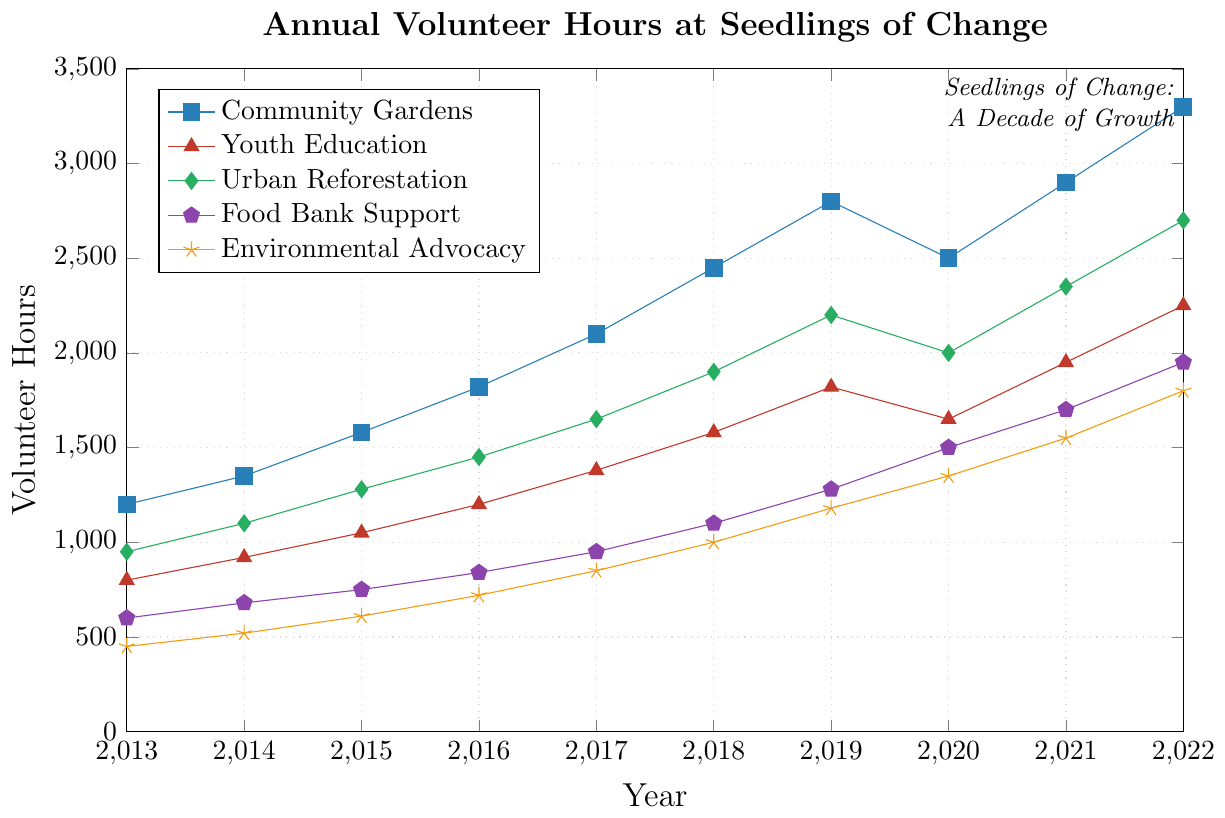What's the general trend of volunteer hours for the Community Gardens over the past decade? The line for Community Gardens rises consistently from 2013 to 2022, indicating a continual increase in volunteer hours each year.
Answer: Consistent Increase Which year had the highest total volunteer hours for Food Bank Support, and what was that value? For Food Bank Support, the highest point on the plot is in 2022 with a value of 1950 hours.
Answer: 2022, 1950 hours In which year did Youth Education experience the largest increase in volunteer hours compared to the previous year, and what was the increase? Youth Education had the largest increase from 2021 to 2022. The increase was 2250 - 1950 = 300 hours.
Answer: 2022, 300 hours Compare the total volunteer hours in 2020 for Community Gardens and Urban Reforestation. Which program had more hours and by how much? In 2020, Community Gardens had 2500 hours and Urban Reforestation had 2000 hours. The difference is 2500 - 2000 = 500 hours.
Answer: Community Gardens, 500 hours What is the average number of volunteer hours contributed to Environmental Advocacy between 2013 and 2022? Sum the volunteer hours from 2013 to 2022 (450 + 520 + 610 + 720 + 850 + 1000 + 1180 + 1350 + 1550 + 1800) to get 11030, then divide by 10 years: 11030 / 10 = 1103 hours.
Answer: 1103 hours Which program had the slowest growth in volunteer hours from 2013 to 2022? By examining the slopes of the lines, Environmental Advocacy had the smallest increase from 450 in 2013 to 1800 in 2022, indicating the slowest growth.
Answer: Environmental Advocacy Estimate the total volunteer hours contributed across all programs in 2017. Sum the volunteer hours for each program in 2017: 2100 (Community Gardens) + 1380 (Youth Education) + 1650 (Urban Reforestation) + 950 (Food Bank Support) + 850 (Environmental Advocacy) = 6930 hours.
Answer: 6930 hours Between 2018 and 2019, which program saw the largest absolute increase in volunteer hours? Compare the increase for each program: Community Gardens (2800 - 2450 = 350), Youth Education (1820 - 1580 = 240), Urban Reforestation (2200 - 1900 = 300), Food Bank Support (1280 - 1100 = 180), Environmental Advocacy (1180 - 1000 = 180). Community Gardens saw the largest increase of 350.
Answer: Community Gardens, 350 hours What visual feature distinguishes the volunteer hours associated with Food Bank Support on the plot? The volunteer hours for Food Bank Support are plotted with pentagon markers.
Answer: Pentagon markers 